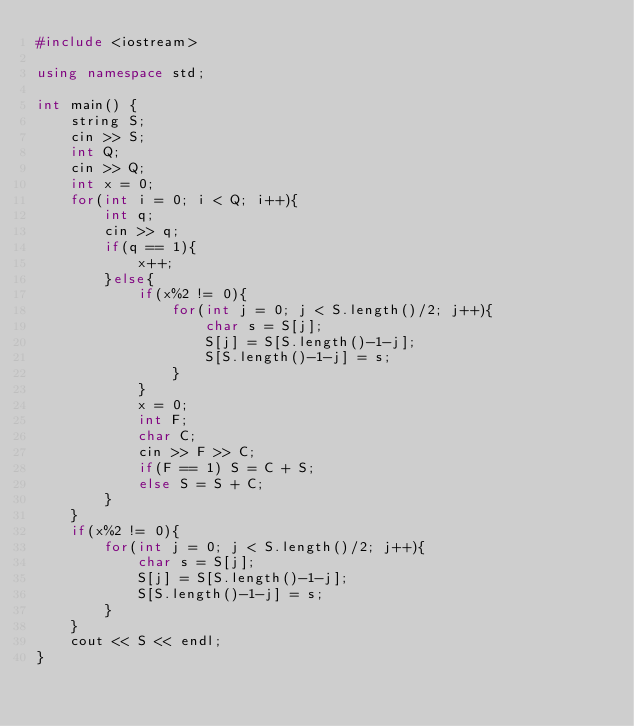Convert code to text. <code><loc_0><loc_0><loc_500><loc_500><_C++_>#include <iostream>

using namespace std;

int main() {
    string S;
    cin >> S;
    int Q;
    cin >> Q;
    int x = 0;
    for(int i = 0; i < Q; i++){
        int q;
        cin >> q;
        if(q == 1){
            x++;
        }else{
            if(x%2 != 0){
                for(int j = 0; j < S.length()/2; j++){
                    char s = S[j];
                    S[j] = S[S.length()-1-j];
                    S[S.length()-1-j] = s;
                }
            }
            x = 0;
            int F;
            char C;
            cin >> F >> C;
            if(F == 1) S = C + S;
            else S = S + C;
        }
    }
    if(x%2 != 0){
        for(int j = 0; j < S.length()/2; j++){
            char s = S[j];
            S[j] = S[S.length()-1-j];
            S[S.length()-1-j] = s;
        }
    }
    cout << S << endl;
}
</code> 